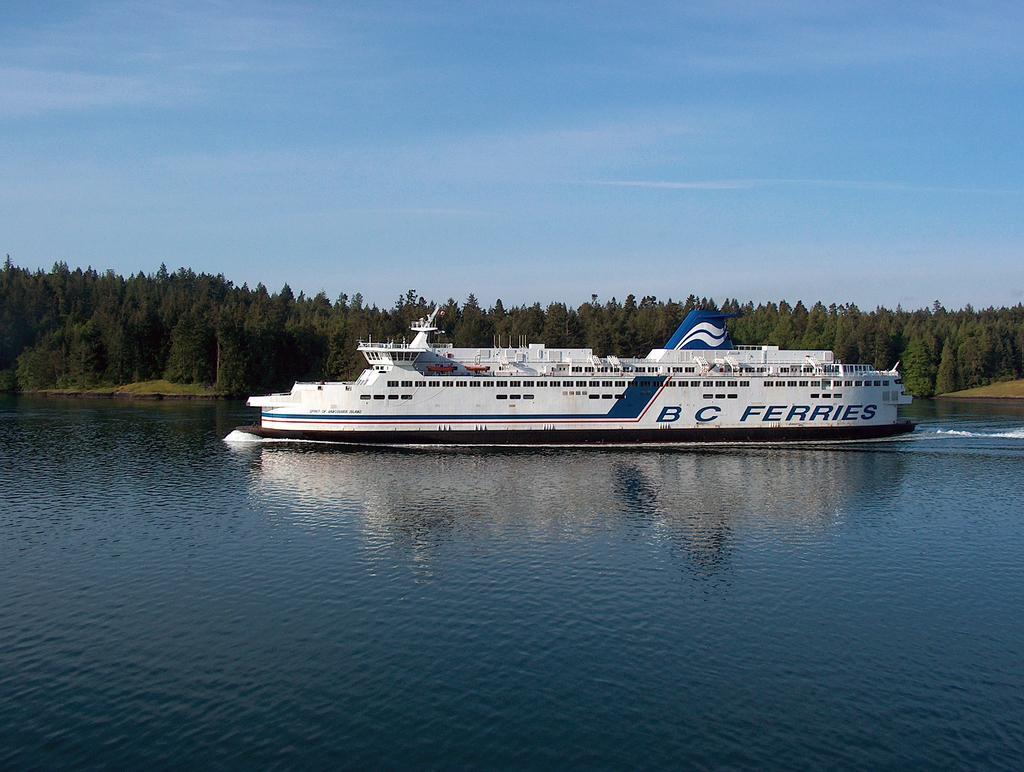Could you give a brief overview of what you see in this image? In this image we can see a ferry which is of white color is on the water and in the background of the image there are some trees and clear sky. 